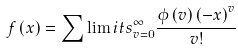Convert formula to latex. <formula><loc_0><loc_0><loc_500><loc_500>f \left ( x \right ) = \sum \lim i t s _ { v = 0 } ^ { \infty } { \frac { { \phi \left ( v \right ) { { \left ( { - x } \right ) } ^ { v } } } } { v ! } }</formula> 